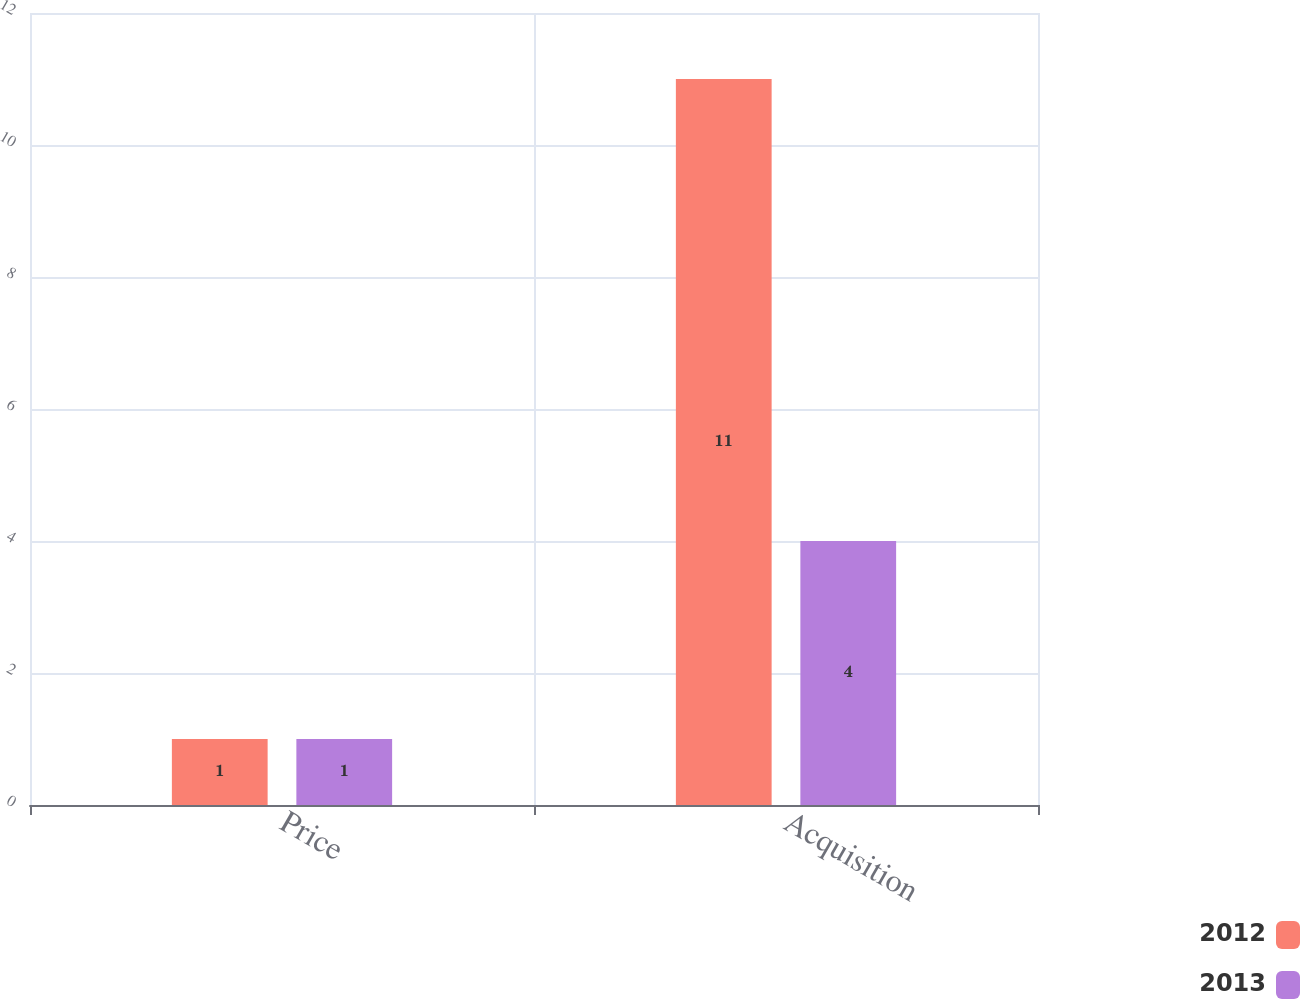Convert chart. <chart><loc_0><loc_0><loc_500><loc_500><stacked_bar_chart><ecel><fcel>Price<fcel>Acquisition<nl><fcel>2012<fcel>1<fcel>11<nl><fcel>2013<fcel>1<fcel>4<nl></chart> 